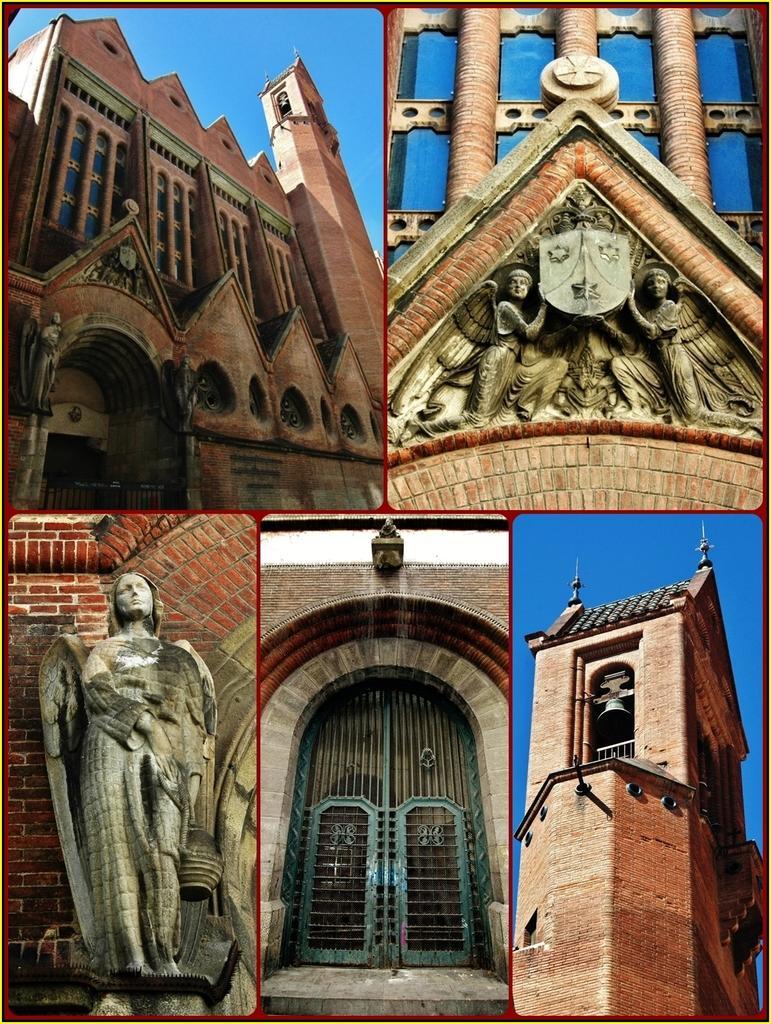Could you give a brief overview of what you see in this image? This is a collage image. In the top left corner we can see a building, door, windows, sky. In the top right corner we can see a building and sculptures. In the bottom left corner we can see a statue and wall. In the bottom right corner we can see a building, bell, roof and sky. At the bottom of the image we can see a door and wall. 